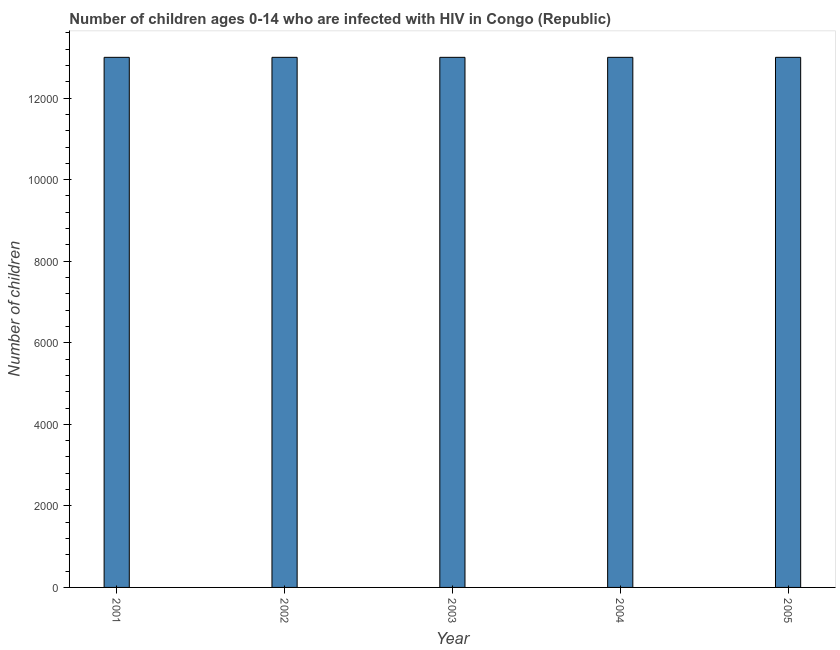Does the graph contain grids?
Offer a terse response. No. What is the title of the graph?
Give a very brief answer. Number of children ages 0-14 who are infected with HIV in Congo (Republic). What is the label or title of the X-axis?
Your answer should be compact. Year. What is the label or title of the Y-axis?
Your answer should be very brief. Number of children. What is the number of children living with hiv in 2004?
Offer a very short reply. 1.30e+04. Across all years, what is the maximum number of children living with hiv?
Offer a very short reply. 1.30e+04. Across all years, what is the minimum number of children living with hiv?
Ensure brevity in your answer.  1.30e+04. In which year was the number of children living with hiv minimum?
Your answer should be compact. 2001. What is the sum of the number of children living with hiv?
Keep it short and to the point. 6.50e+04. What is the difference between the number of children living with hiv in 2001 and 2003?
Give a very brief answer. 0. What is the average number of children living with hiv per year?
Your answer should be very brief. 1.30e+04. What is the median number of children living with hiv?
Ensure brevity in your answer.  1.30e+04. In how many years, is the number of children living with hiv greater than 3600 ?
Provide a succinct answer. 5. Do a majority of the years between 2003 and 2005 (inclusive) have number of children living with hiv greater than 5200 ?
Offer a terse response. Yes. Is the difference between the number of children living with hiv in 2001 and 2002 greater than the difference between any two years?
Keep it short and to the point. Yes. Is the sum of the number of children living with hiv in 2001 and 2005 greater than the maximum number of children living with hiv across all years?
Provide a succinct answer. Yes. How many years are there in the graph?
Provide a short and direct response. 5. What is the difference between two consecutive major ticks on the Y-axis?
Provide a short and direct response. 2000. What is the Number of children in 2001?
Your answer should be very brief. 1.30e+04. What is the Number of children in 2002?
Keep it short and to the point. 1.30e+04. What is the Number of children of 2003?
Provide a short and direct response. 1.30e+04. What is the Number of children of 2004?
Make the answer very short. 1.30e+04. What is the Number of children in 2005?
Offer a very short reply. 1.30e+04. What is the difference between the Number of children in 2001 and 2002?
Offer a terse response. 0. What is the difference between the Number of children in 2001 and 2003?
Make the answer very short. 0. What is the difference between the Number of children in 2001 and 2004?
Provide a succinct answer. 0. What is the difference between the Number of children in 2001 and 2005?
Your answer should be compact. 0. What is the difference between the Number of children in 2003 and 2004?
Your response must be concise. 0. What is the ratio of the Number of children in 2001 to that in 2004?
Ensure brevity in your answer.  1. What is the ratio of the Number of children in 2002 to that in 2003?
Your answer should be very brief. 1. What is the ratio of the Number of children in 2002 to that in 2004?
Keep it short and to the point. 1. What is the ratio of the Number of children in 2002 to that in 2005?
Provide a short and direct response. 1. What is the ratio of the Number of children in 2003 to that in 2004?
Provide a short and direct response. 1. 